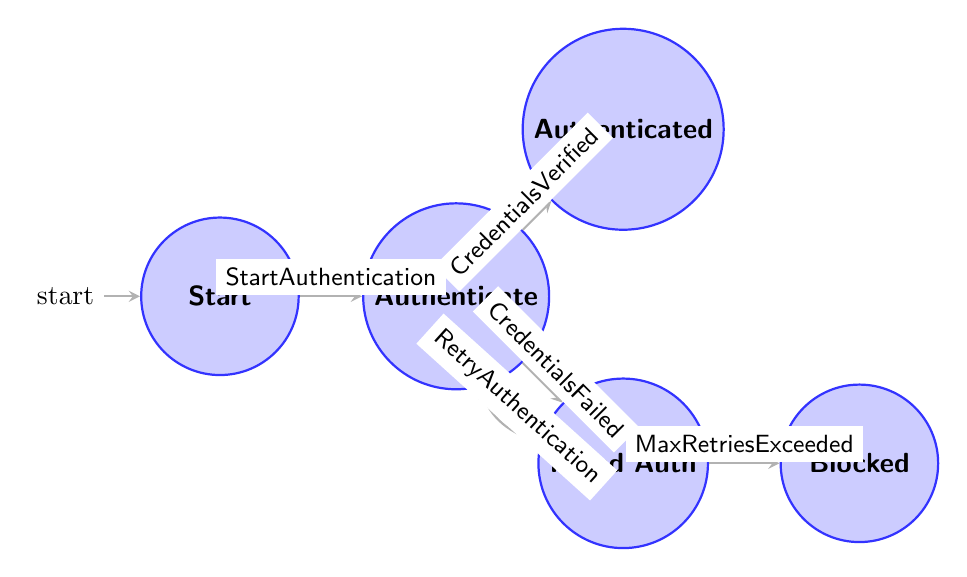What's the initial state of the Finite State Machine? The initial state is defined as "Start," where no authentication has yet been attempted.
Answer: Start How many states are there in the diagram? The diagram lists five distinct states: Start, Authenticate, Authenticated, Failed Authentication, and Blocked. Therefore, the total count is five.
Answer: 5 What transition occurs when user credentials are verified successfully? The transition occurs from "Authenticate" to "Authenticated" upon the trigger labeled "CredentialsVerified."
Answer: Authenticated What happens after a user exceeds the maximum number of failed authentication attempts? If the maximum number is exceeded, the state transitions from "FailedAuthentication" to "Blocked."
Answer: Blocked What is the trigger for moving from "Start" to "Authenticate"? The transition from "Start" to "Authenticate" is activated by the trigger "StartAuthentication."
Answer: StartAuthentication If a user fails authentication, which state do they enter? Upon failing authentication, the user enters the "FailedAuthentication" state as indicated by the transition from "Authenticate."
Answer: FailedAuthentication Which state can be reached again after failing authentication? After entering the "FailedAuthentication" state, the user can attempt to authenticate again and can move back to "Authenticate" via the trigger "RetryAuthentication."
Answer: Authenticate What is the relationship between "FailedAuthentication" and "Blocked"? The relationship is that "FailedAuthentication" can transition to "Blocked" if the user has exceeded the maximum number of failed authentication attempts, through the trigger "MaxRetriesExceeded."
Answer: Blocked 